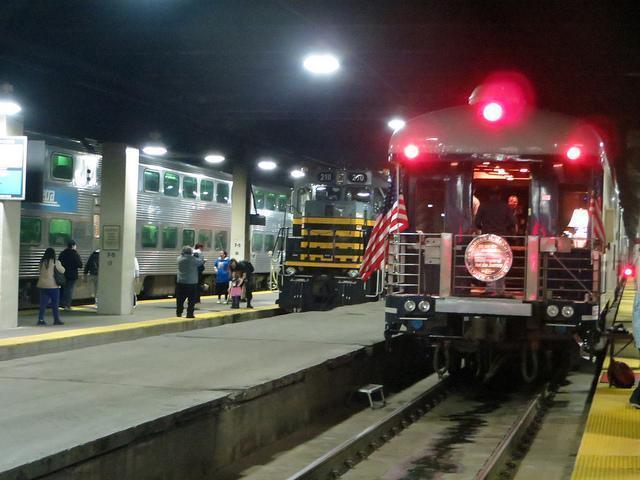How many red lights are there?
Give a very brief answer. 3. How many people are in the front of the train?
Give a very brief answer. 0. How many trains are in the photo?
Give a very brief answer. 3. How many cars are in the train?
Give a very brief answer. 0. 